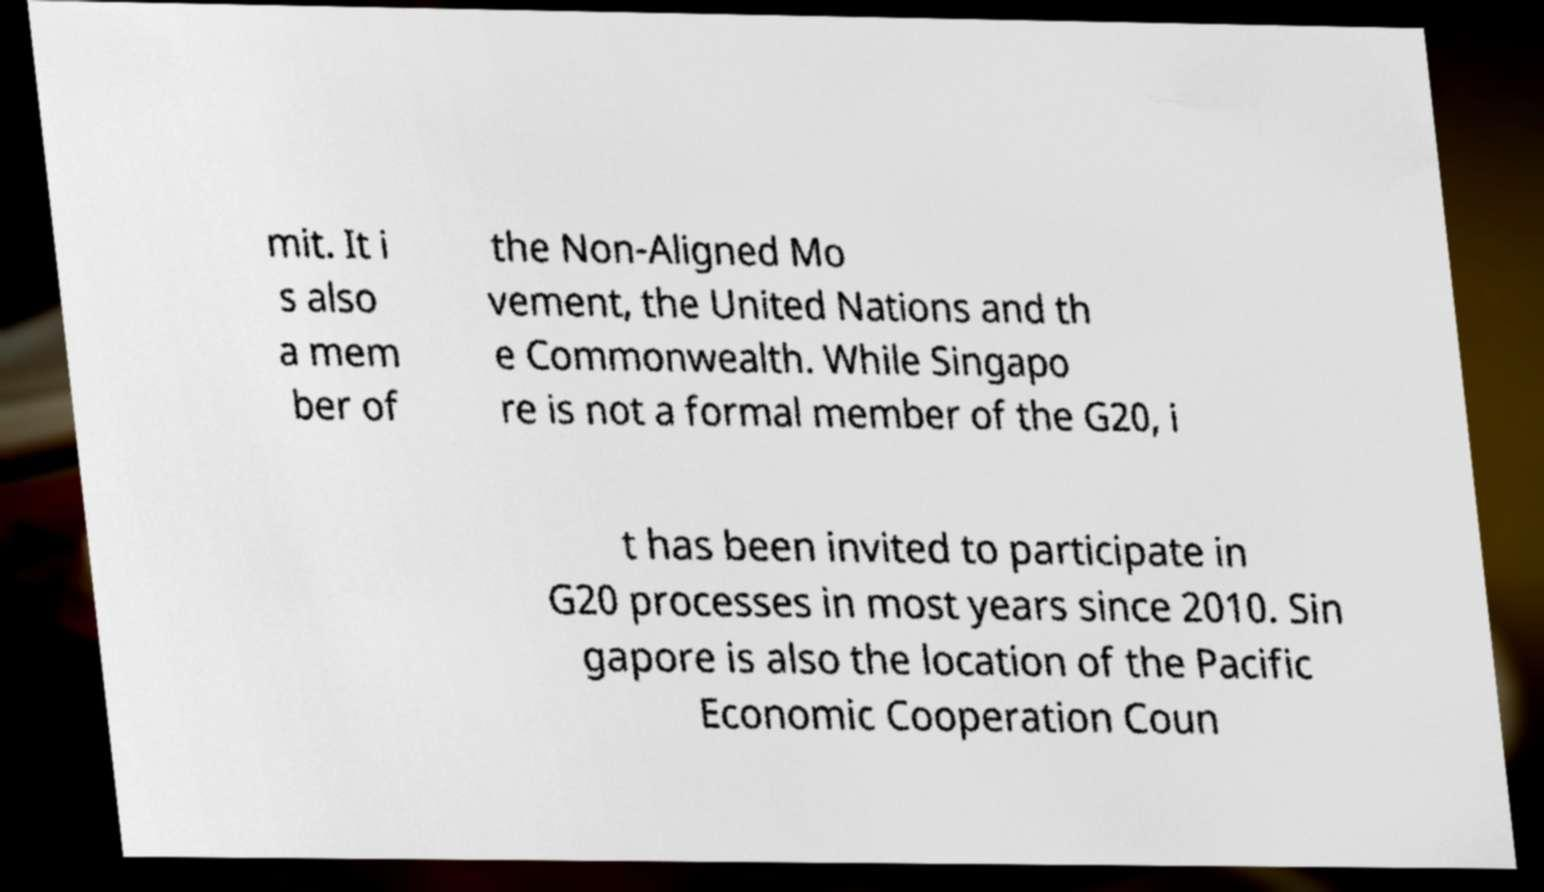Can you read and provide the text displayed in the image?This photo seems to have some interesting text. Can you extract and type it out for me? mit. It i s also a mem ber of the Non-Aligned Mo vement, the United Nations and th e Commonwealth. While Singapo re is not a formal member of the G20, i t has been invited to participate in G20 processes in most years since 2010. Sin gapore is also the location of the Pacific Economic Cooperation Coun 